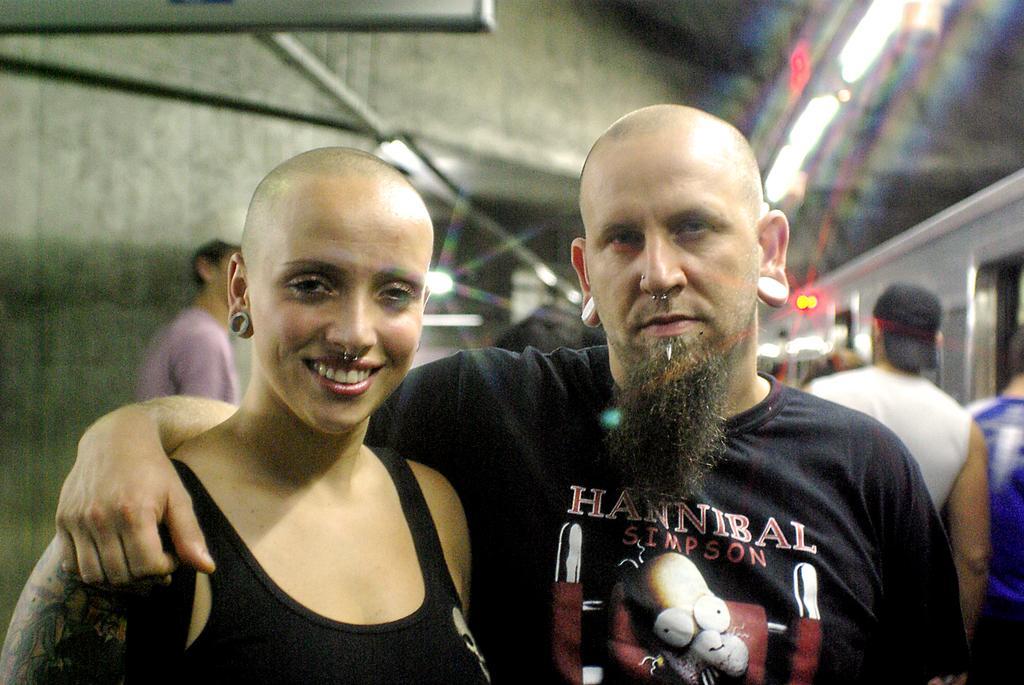Could you give a brief overview of what you see in this image? As we can see in the image in the front there are two persons. The women who is standing on the left is wearing black color dress and the man who is standing on the right is wearing black color t shirt. Behind these two persons there are another two persons. The man who is standing on the right is wearing black color cap and white color t shirt. 